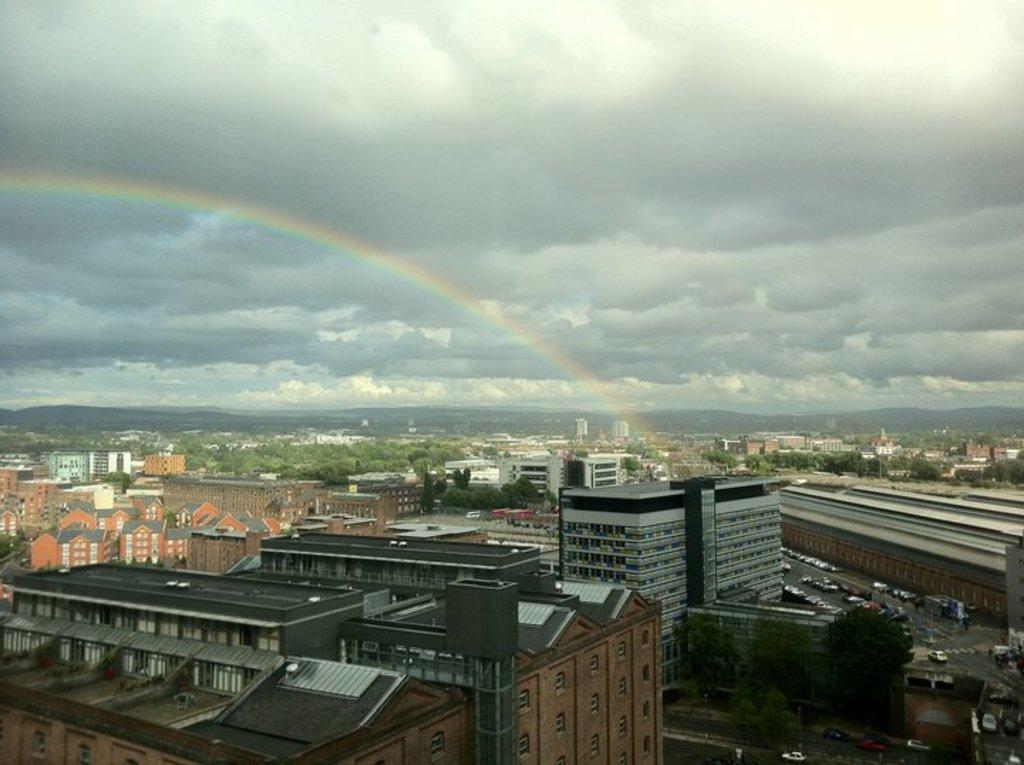In one or two sentences, can you explain what this image depicts? In this picture, we can see some buildings and few vehicles which are moving on the road. In the background, we can see some trees, buildings, mountains, rainbow. At the top, we can see a sky which is cloudy. 